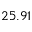<formula> <loc_0><loc_0><loc_500><loc_500>2 5 . 9 1</formula> 